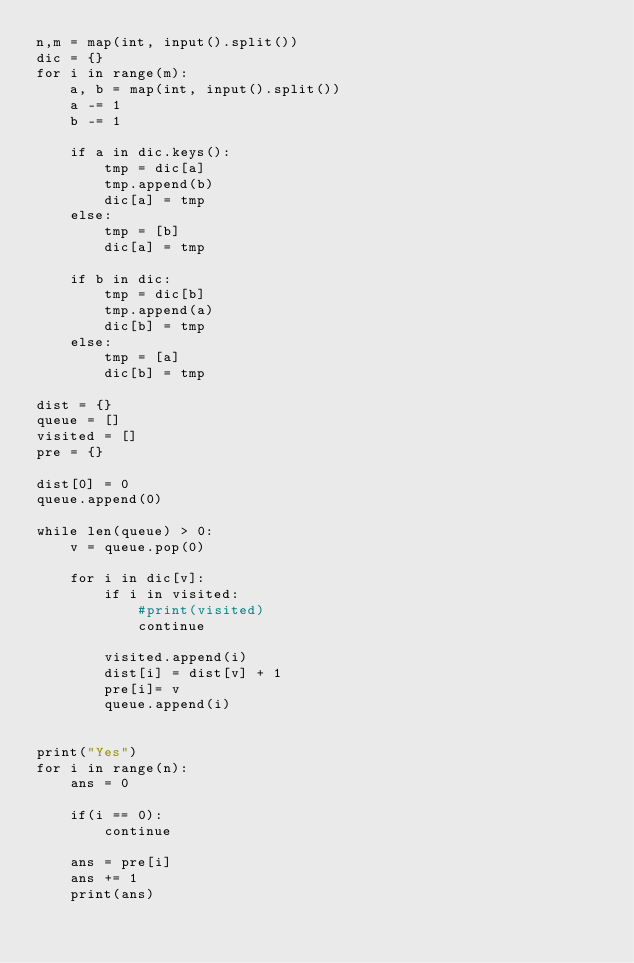<code> <loc_0><loc_0><loc_500><loc_500><_Python_>n,m = map(int, input().split())
dic = {}
for i in range(m):
    a, b = map(int, input().split())
    a -= 1
    b -= 1
    
    if a in dic.keys():
        tmp = dic[a]
        tmp.append(b)
        dic[a] = tmp
    else:
        tmp = [b]
        dic[a] = tmp
    
    if b in dic:
        tmp = dic[b]
        tmp.append(a)
        dic[b] = tmp
    else:
        tmp = [a]
        dic[b] = tmp

dist = {}
queue = []
visited = []
pre = {}

dist[0] = 0 
queue.append(0)

while len(queue) > 0:
    v = queue.pop(0)
    
    for i in dic[v]:
        if i in visited:
            #print(visited)
            continue
        
        visited.append(i)
        dist[i] = dist[v] + 1
        pre[i]= v
        queue.append(i)


print("Yes")
for i in range(n):
    ans = 0
    
    if(i == 0):
        continue
    
    ans = pre[i]
    ans += 1
    print(ans)</code> 